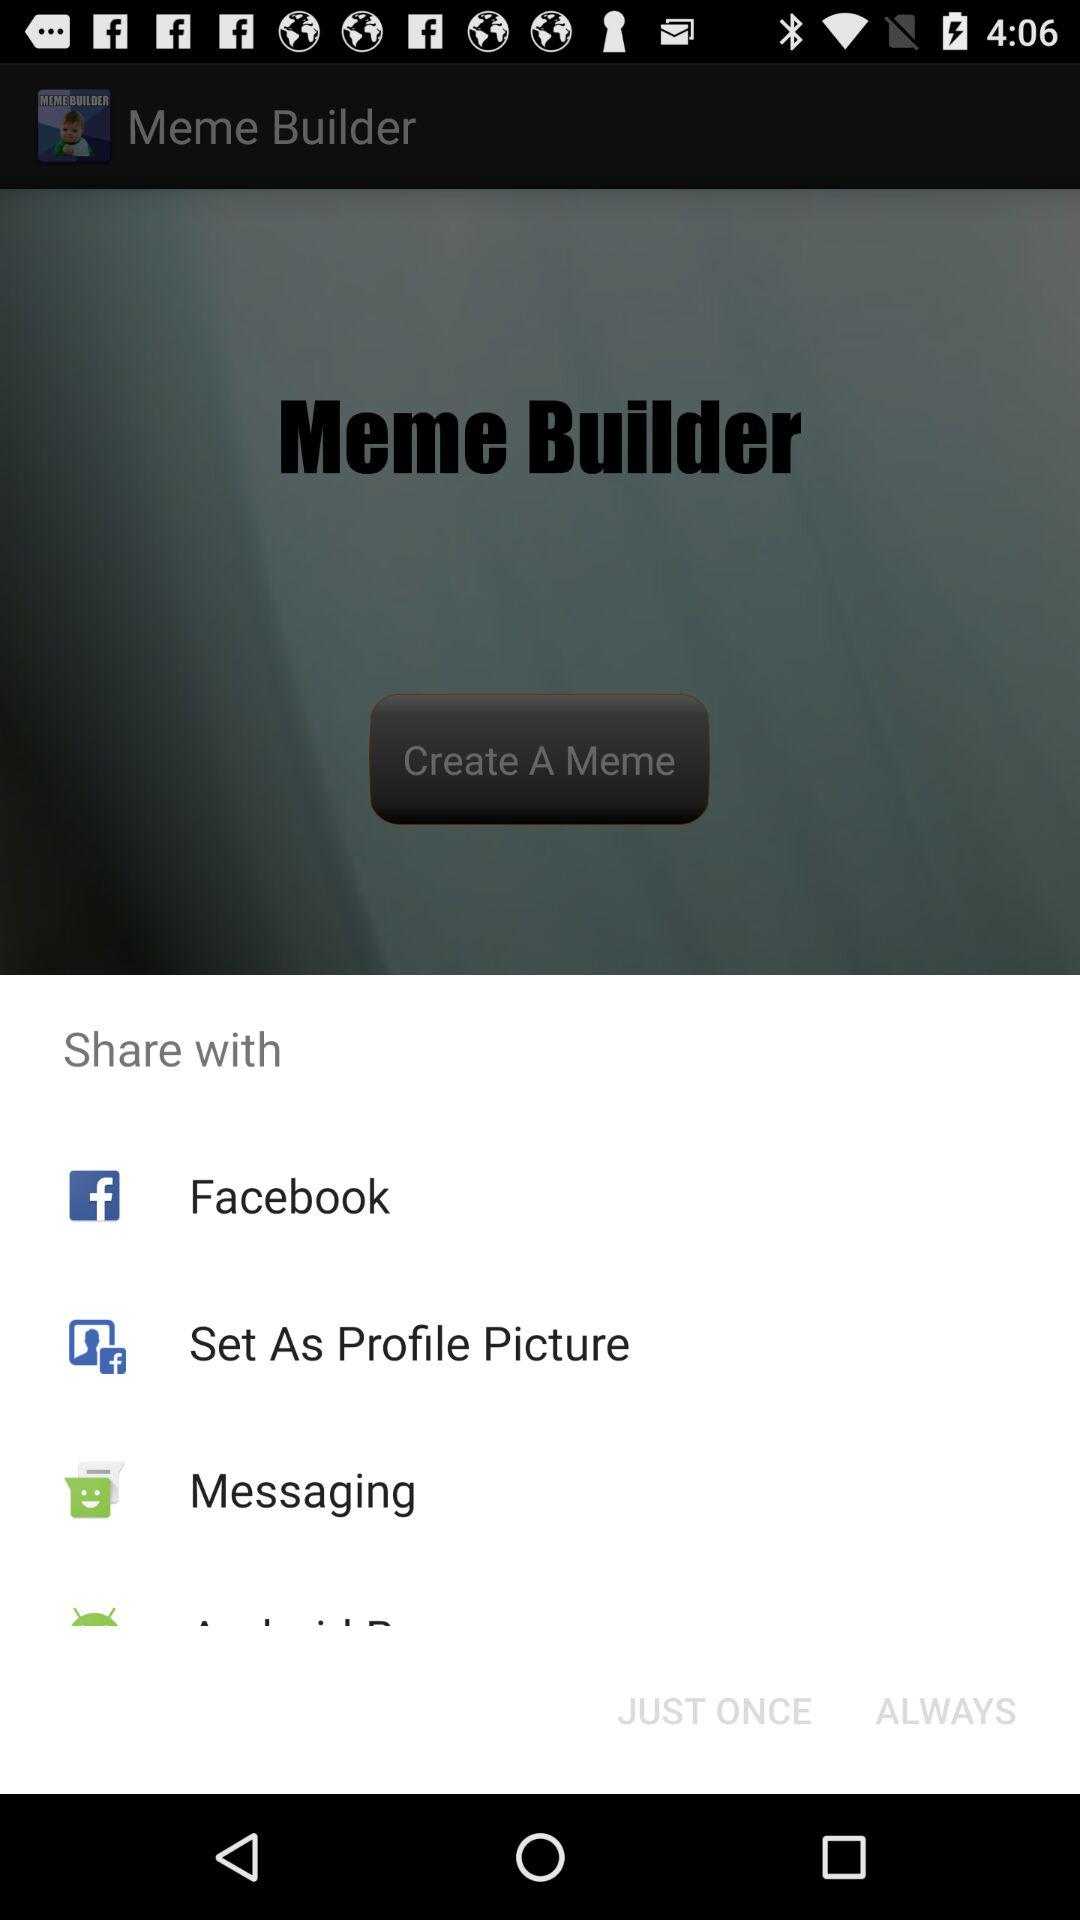What are the sharing options? The sharing options are "Facebook", "Set As Profile Picture" and "Messaging". 